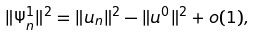Convert formula to latex. <formula><loc_0><loc_0><loc_500><loc_500>\| \Psi _ { n } ^ { 1 } \| ^ { 2 } = \| u _ { n } \| ^ { 2 } - \| u ^ { 0 } \| ^ { 2 } + o ( 1 ) ,</formula> 